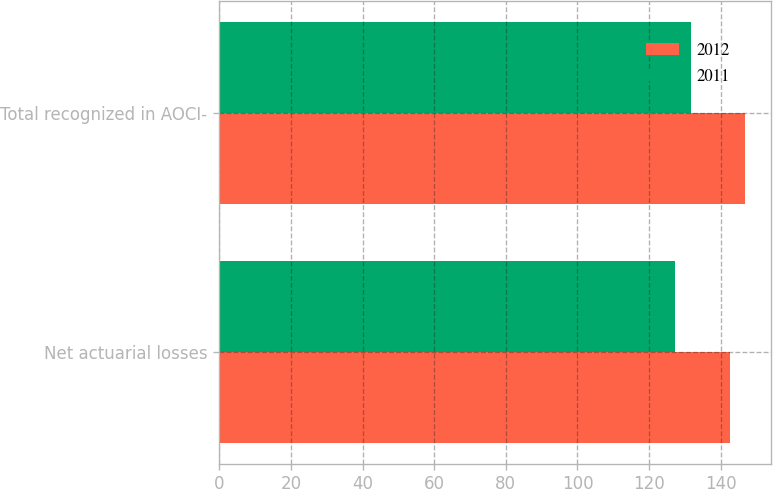<chart> <loc_0><loc_0><loc_500><loc_500><stacked_bar_chart><ecel><fcel>Net actuarial losses<fcel>Total recognized in AOCI-<nl><fcel>2012<fcel>142.7<fcel>146.7<nl><fcel>2011<fcel>127.1<fcel>131.8<nl></chart> 